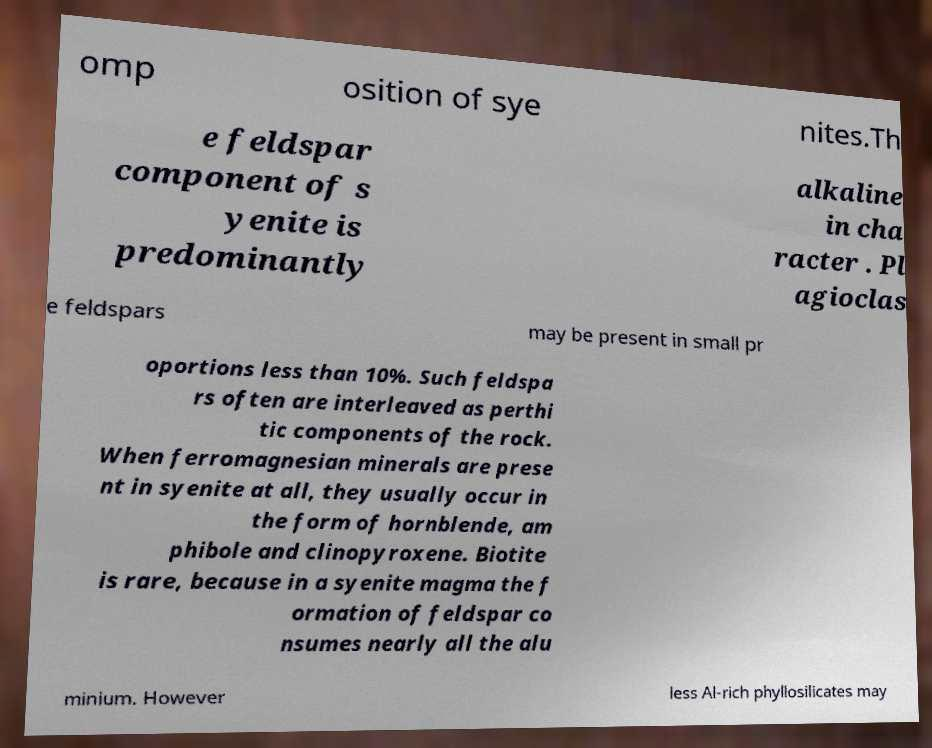Can you accurately transcribe the text from the provided image for me? omp osition of sye nites.Th e feldspar component of s yenite is predominantly alkaline in cha racter . Pl agioclas e feldspars may be present in small pr oportions less than 10%. Such feldspa rs often are interleaved as perthi tic components of the rock. When ferromagnesian minerals are prese nt in syenite at all, they usually occur in the form of hornblende, am phibole and clinopyroxene. Biotite is rare, because in a syenite magma the f ormation of feldspar co nsumes nearly all the alu minium. However less Al-rich phyllosilicates may 